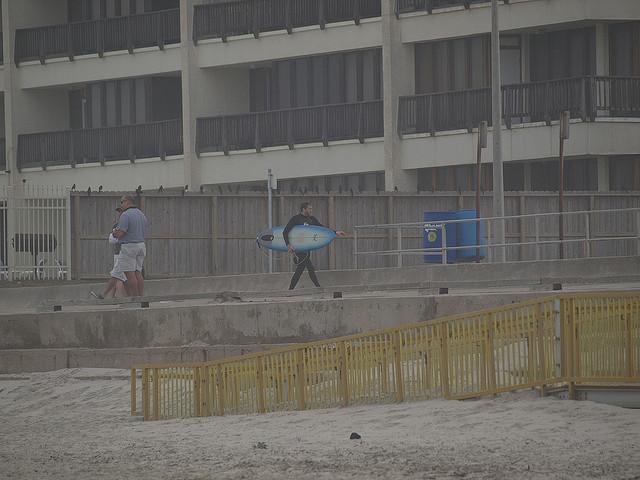How many people are visible?
Give a very brief answer. 3. 